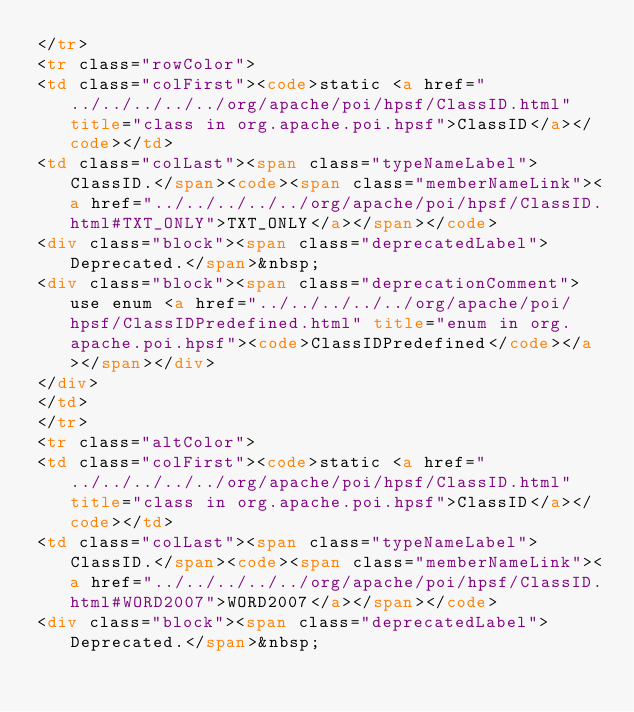<code> <loc_0><loc_0><loc_500><loc_500><_HTML_></tr>
<tr class="rowColor">
<td class="colFirst"><code>static <a href="../../../../../org/apache/poi/hpsf/ClassID.html" title="class in org.apache.poi.hpsf">ClassID</a></code></td>
<td class="colLast"><span class="typeNameLabel">ClassID.</span><code><span class="memberNameLink"><a href="../../../../../org/apache/poi/hpsf/ClassID.html#TXT_ONLY">TXT_ONLY</a></span></code>
<div class="block"><span class="deprecatedLabel">Deprecated.</span>&nbsp;
<div class="block"><span class="deprecationComment">use enum <a href="../../../../../org/apache/poi/hpsf/ClassIDPredefined.html" title="enum in org.apache.poi.hpsf"><code>ClassIDPredefined</code></a></span></div>
</div>
</td>
</tr>
<tr class="altColor">
<td class="colFirst"><code>static <a href="../../../../../org/apache/poi/hpsf/ClassID.html" title="class in org.apache.poi.hpsf">ClassID</a></code></td>
<td class="colLast"><span class="typeNameLabel">ClassID.</span><code><span class="memberNameLink"><a href="../../../../../org/apache/poi/hpsf/ClassID.html#WORD2007">WORD2007</a></span></code>
<div class="block"><span class="deprecatedLabel">Deprecated.</span>&nbsp;</code> 